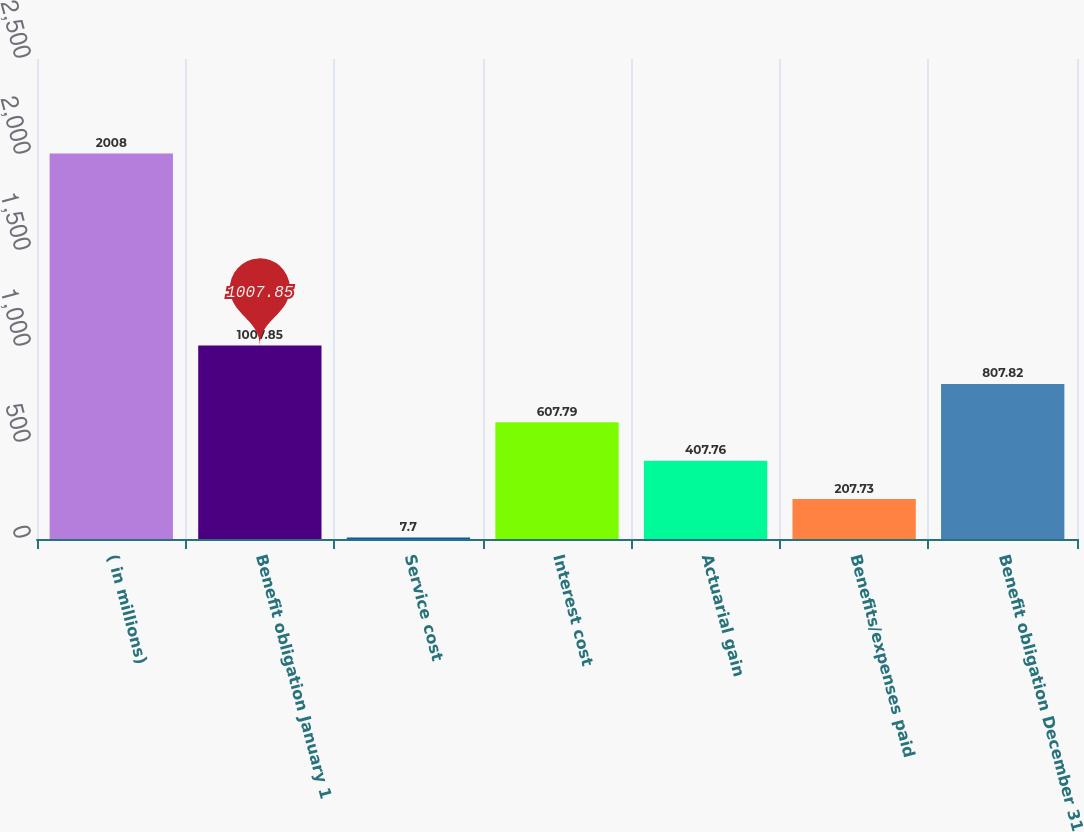Convert chart. <chart><loc_0><loc_0><loc_500><loc_500><bar_chart><fcel>( in millions)<fcel>Benefit obligation January 1<fcel>Service cost<fcel>Interest cost<fcel>Actuarial gain<fcel>Benefits/expenses paid<fcel>Benefit obligation December 31<nl><fcel>2008<fcel>1007.85<fcel>7.7<fcel>607.79<fcel>407.76<fcel>207.73<fcel>807.82<nl></chart> 